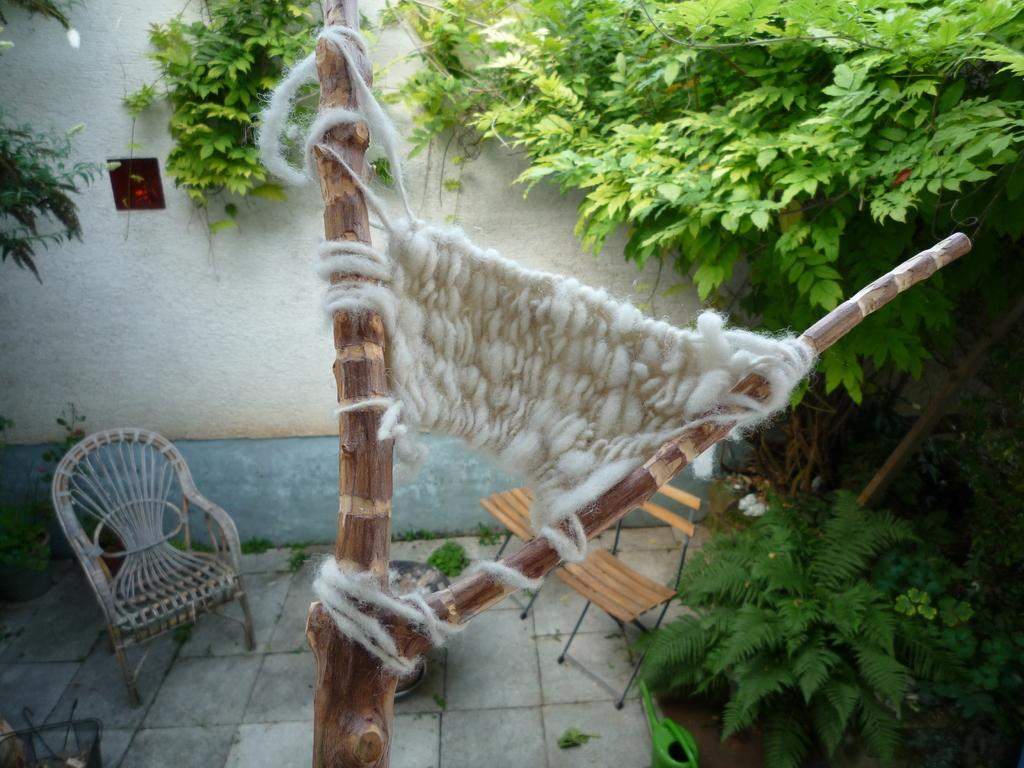What is the main subject in the center of the image? There is a branch weaving in the center of the image. What can be seen in the background of the image? There are trees and chairs in the background of the image. What is on the wall in the background of the image? There is a board on the wall in the background of the image. What is visible at the bottom of the image? There is a floor visible at the bottom of the image. How many geese are sitting on the branch in the image? There are no geese present in the image; it features a branch weaving in the center. What type of bag is hanging from the branch in the image? There is no bag hanging from the branch in the image; it only features a branch weaving. 